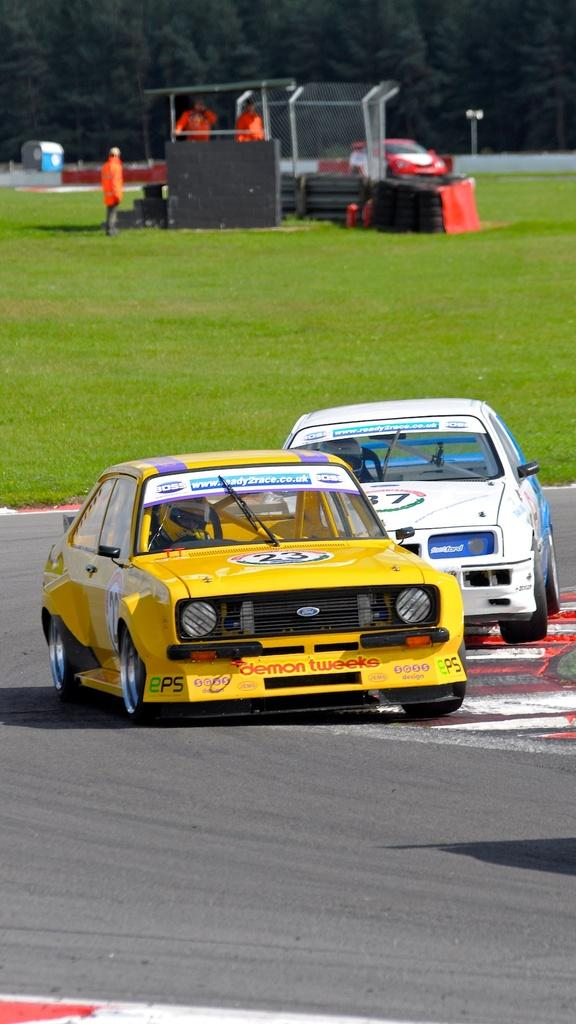How many vehicles can be seen in the image? There are three vehicles in the image. What type of terrain is visible in the image? There is grass visible in the image. How many people are present in the image? There are three persons standing in the image. What objects related to the vehicles can be seen in the image? There are tyres in the image. What can be seen in the background of the image? There are trees in the background of the image. What type of agreement is being discussed by the persons in the image? There is no indication in the image that the persons are discussing any agreement. Can you see a rifle in the image? No, there is no rifle present in the image. 